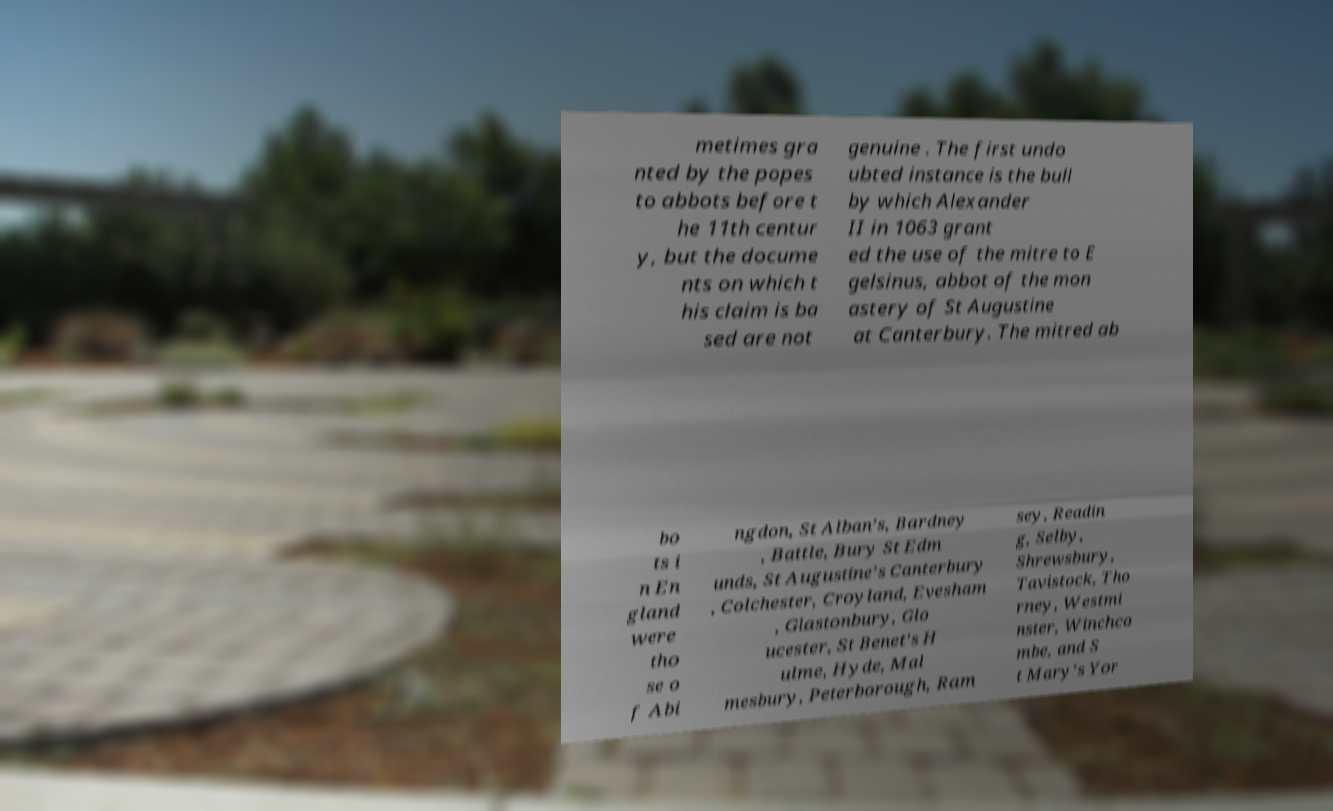There's text embedded in this image that I need extracted. Can you transcribe it verbatim? metimes gra nted by the popes to abbots before t he 11th centur y, but the docume nts on which t his claim is ba sed are not genuine . The first undo ubted instance is the bull by which Alexander II in 1063 grant ed the use of the mitre to E gelsinus, abbot of the mon astery of St Augustine at Canterbury. The mitred ab bo ts i n En gland were tho se o f Abi ngdon, St Alban's, Bardney , Battle, Bury St Edm unds, St Augustine's Canterbury , Colchester, Croyland, Evesham , Glastonbury, Glo ucester, St Benet's H ulme, Hyde, Mal mesbury, Peterborough, Ram sey, Readin g, Selby, Shrewsbury, Tavistock, Tho rney, Westmi nster, Winchco mbe, and S t Mary's Yor 